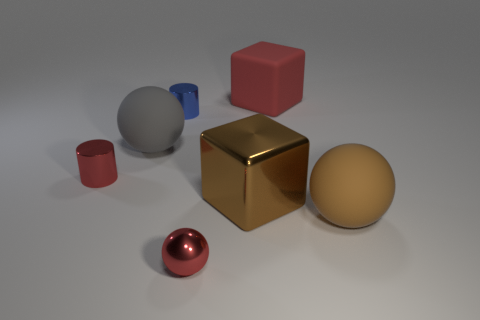Subtract all matte balls. How many balls are left? 1 Add 2 big brown shiny blocks. How many objects exist? 9 Subtract all red cylinders. How many cylinders are left? 1 Subtract all cylinders. How many objects are left? 5 Subtract 2 cylinders. How many cylinders are left? 0 Subtract all purple balls. Subtract all yellow cylinders. How many balls are left? 3 Subtract all brown cylinders. How many brown balls are left? 1 Subtract all rubber objects. Subtract all metal spheres. How many objects are left? 3 Add 1 big brown rubber objects. How many big brown rubber objects are left? 2 Add 2 large red things. How many large red things exist? 3 